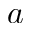<formula> <loc_0><loc_0><loc_500><loc_500>a</formula> 